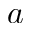<formula> <loc_0><loc_0><loc_500><loc_500>a</formula> 